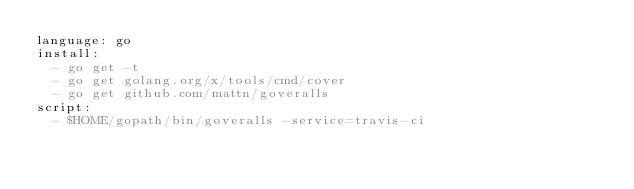Convert code to text. <code><loc_0><loc_0><loc_500><loc_500><_YAML_>language: go
install:
  - go get -t
  - go get golang.org/x/tools/cmd/cover
  - go get github.com/mattn/goveralls
script:
  - $HOME/gopath/bin/goveralls -service=travis-ci
</code> 